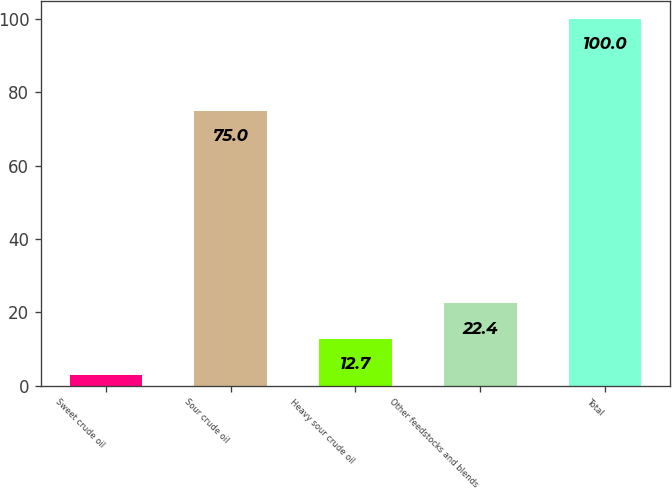<chart> <loc_0><loc_0><loc_500><loc_500><bar_chart><fcel>Sweet crude oil<fcel>Sour crude oil<fcel>Heavy sour crude oil<fcel>Other feedstocks and blends<fcel>Total<nl><fcel>3<fcel>75<fcel>12.7<fcel>22.4<fcel>100<nl></chart> 